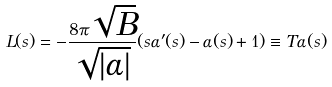<formula> <loc_0><loc_0><loc_500><loc_500>L ( s ) = - \frac { 8 \pi \sqrt { B } } { \sqrt { | \alpha | } } ( s \alpha ^ { \prime } ( s ) - \alpha ( s ) + 1 ) \equiv T \alpha ( s )</formula> 